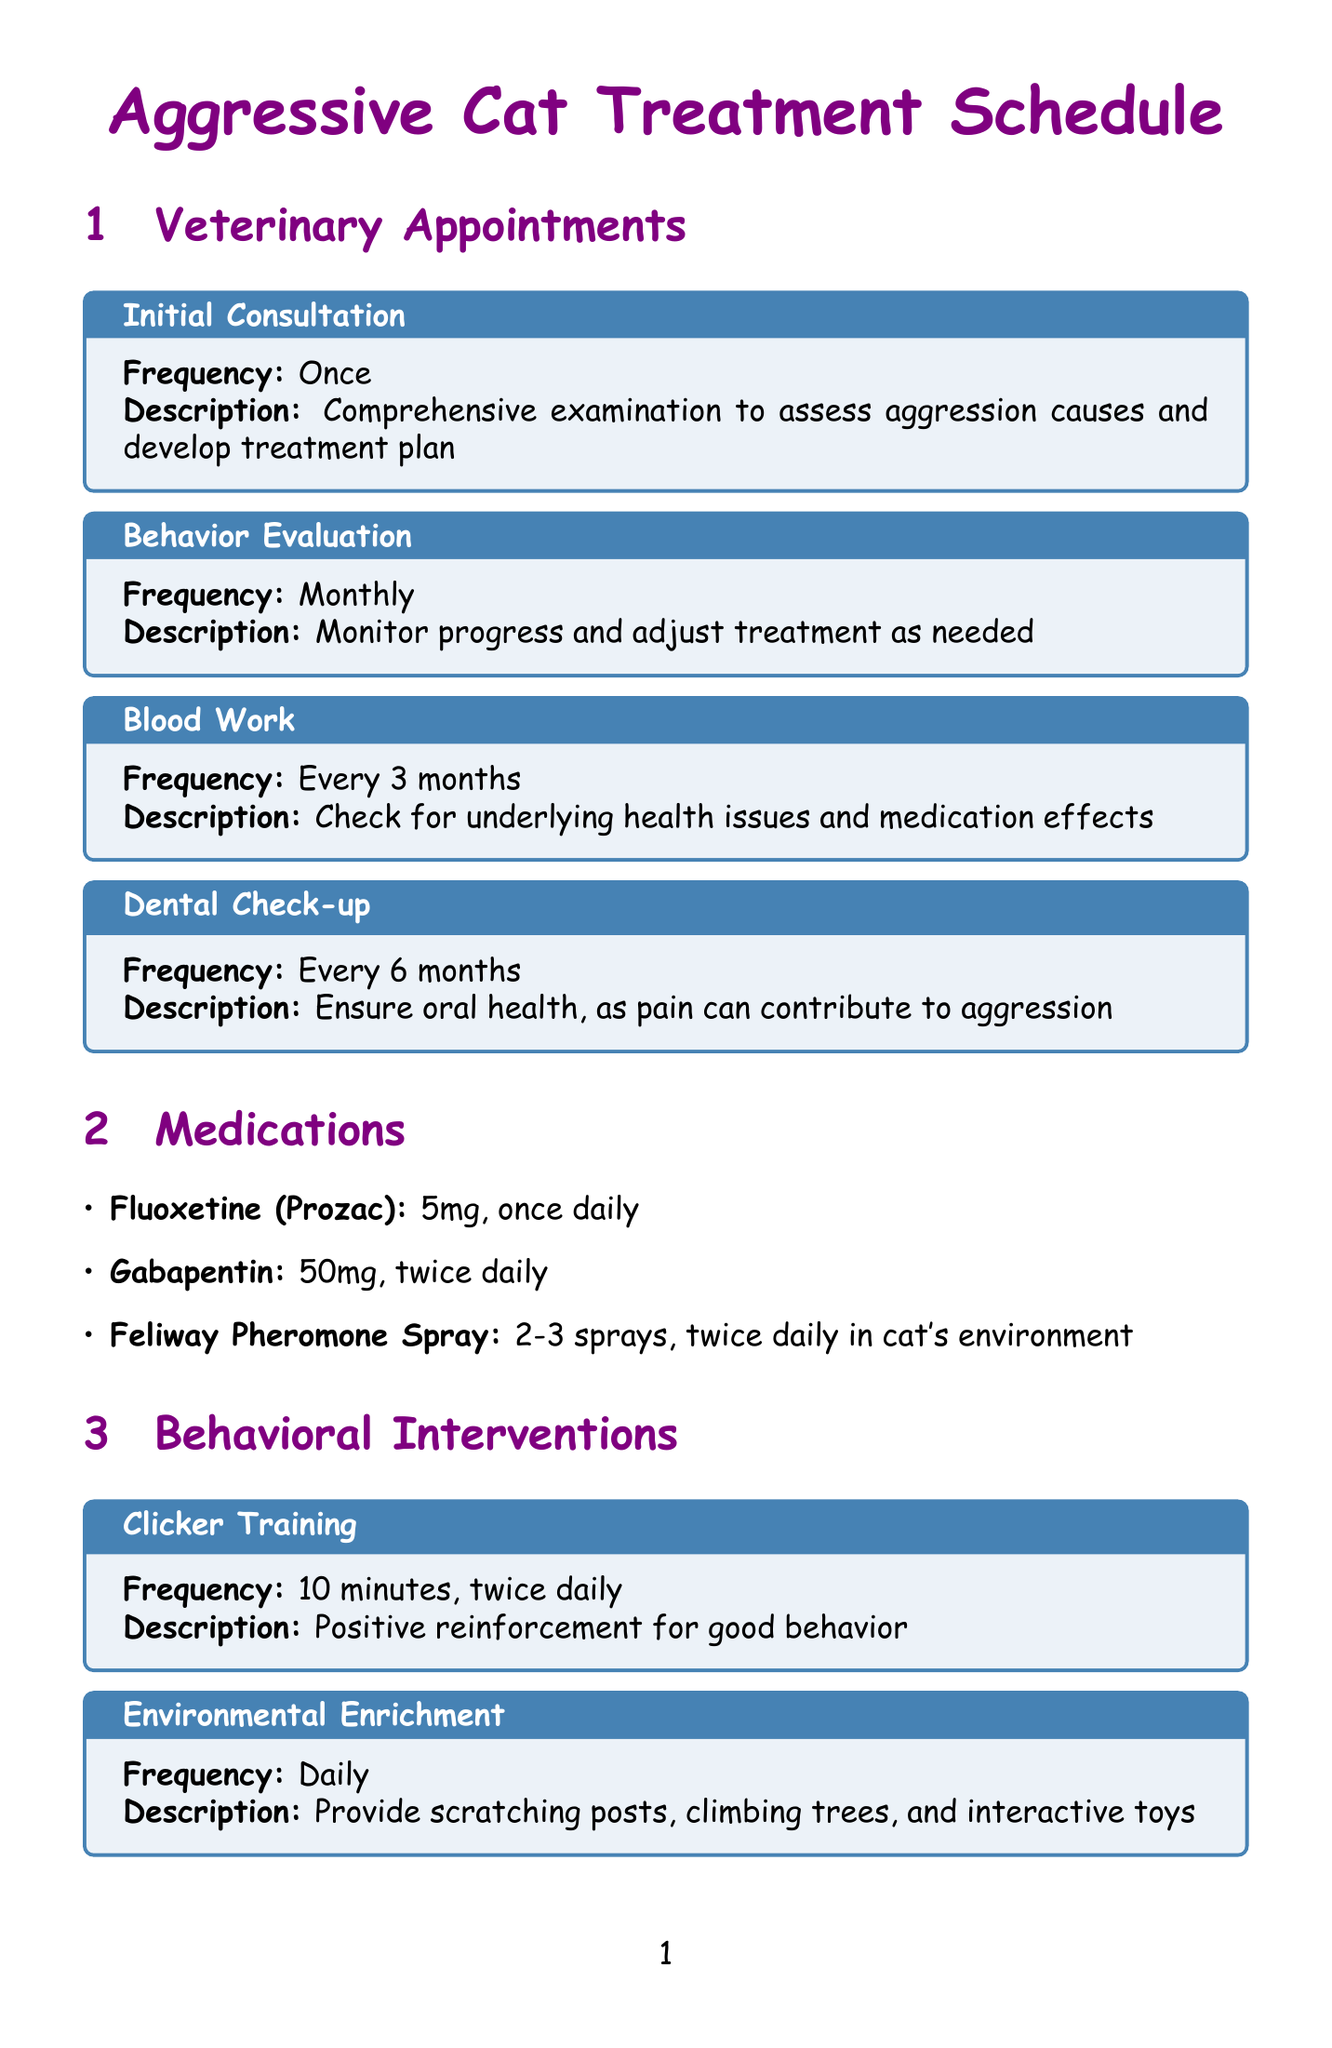What is the frequency of the Initial Consultation? The frequency of the Initial Consultation is indicated as “Once” in the document.
Answer: Once How often should behavior evaluations take place? The document states that Behavior Evaluations should occur monthly.
Answer: Monthly What is the purpose of Fluoxetine (Prozac)? The document describes the purpose as reducing anxiety and aggression.
Answer: Reduce anxiety and aggression How frequently should dental check-ups occur? According to the document, dental check-ups occur every 6 months.
Answer: Every 6 months What action should be taken daily to keep track of aggression? The document specifies to keep an Aggression Journal daily.
Answer: Keep Aggression Journal What dosage of Gabapentin should be administered? The document states that Gabapentin should be given at a dosage of 50mg.
Answer: 50mg How long should clicker training sessions be? The document indicates that clicker training sessions should last for 10 minutes.
Answer: 10 minutes What is the main purpose of Zylkene? The document indicates that it is a natural calming supplement.
Answer: Natural calming supplement How often should video recordings be made? The document mentions that video recordings should be made weekly.
Answer: Weekly 